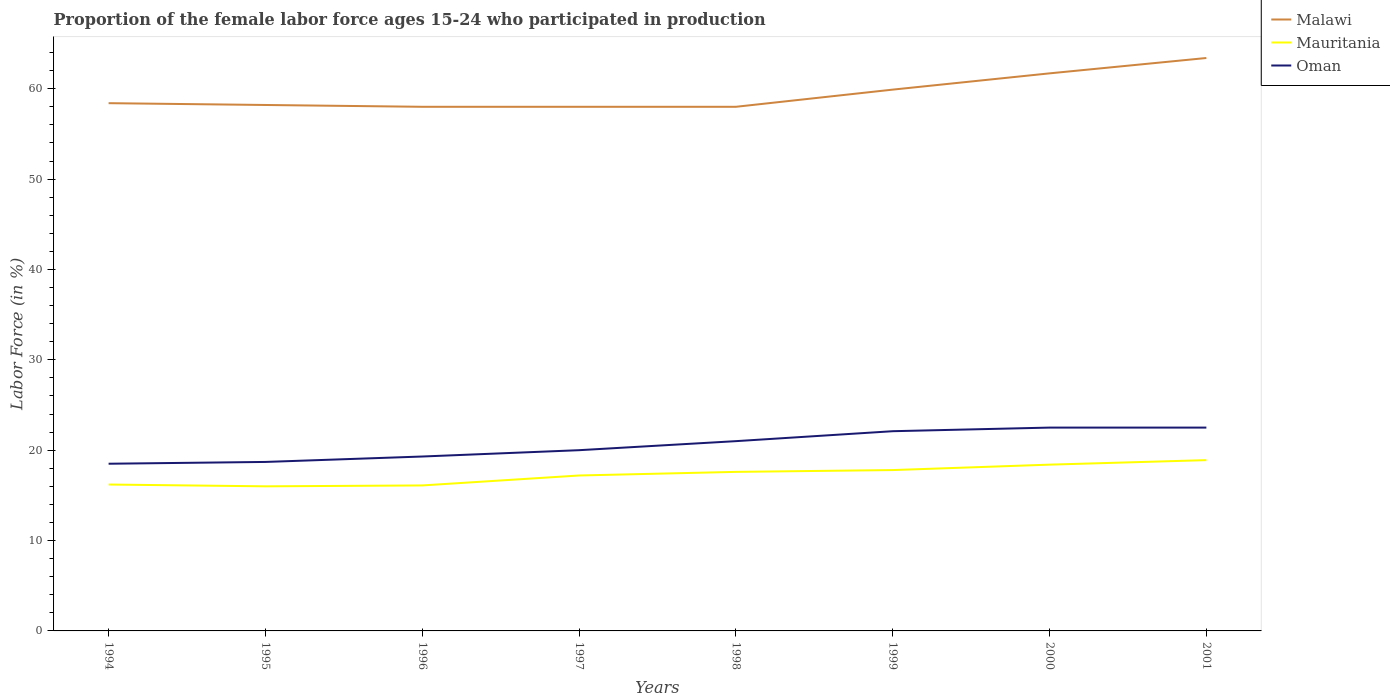How many different coloured lines are there?
Offer a very short reply. 3. Does the line corresponding to Oman intersect with the line corresponding to Malawi?
Make the answer very short. No. Is the number of lines equal to the number of legend labels?
Your response must be concise. Yes. Across all years, what is the maximum proportion of the female labor force who participated in production in Oman?
Ensure brevity in your answer.  18.5. What is the total proportion of the female labor force who participated in production in Oman in the graph?
Keep it short and to the point. -3.4. Is the proportion of the female labor force who participated in production in Malawi strictly greater than the proportion of the female labor force who participated in production in Mauritania over the years?
Ensure brevity in your answer.  No. Are the values on the major ticks of Y-axis written in scientific E-notation?
Offer a terse response. No. Does the graph contain any zero values?
Give a very brief answer. No. Does the graph contain grids?
Your answer should be compact. No. Where does the legend appear in the graph?
Ensure brevity in your answer.  Top right. How many legend labels are there?
Your answer should be very brief. 3. What is the title of the graph?
Make the answer very short. Proportion of the female labor force ages 15-24 who participated in production. What is the label or title of the X-axis?
Offer a very short reply. Years. What is the Labor Force (in %) of Malawi in 1994?
Provide a short and direct response. 58.4. What is the Labor Force (in %) of Mauritania in 1994?
Offer a very short reply. 16.2. What is the Labor Force (in %) in Oman in 1994?
Your answer should be very brief. 18.5. What is the Labor Force (in %) of Malawi in 1995?
Make the answer very short. 58.2. What is the Labor Force (in %) in Mauritania in 1995?
Give a very brief answer. 16. What is the Labor Force (in %) in Oman in 1995?
Offer a terse response. 18.7. What is the Labor Force (in %) of Malawi in 1996?
Offer a terse response. 58. What is the Labor Force (in %) in Mauritania in 1996?
Provide a short and direct response. 16.1. What is the Labor Force (in %) in Oman in 1996?
Make the answer very short. 19.3. What is the Labor Force (in %) of Malawi in 1997?
Provide a succinct answer. 58. What is the Labor Force (in %) in Mauritania in 1997?
Your answer should be compact. 17.2. What is the Labor Force (in %) in Oman in 1997?
Your answer should be very brief. 20. What is the Labor Force (in %) in Mauritania in 1998?
Provide a succinct answer. 17.6. What is the Labor Force (in %) in Oman in 1998?
Your answer should be very brief. 21. What is the Labor Force (in %) of Malawi in 1999?
Give a very brief answer. 59.9. What is the Labor Force (in %) of Mauritania in 1999?
Your answer should be very brief. 17.8. What is the Labor Force (in %) in Oman in 1999?
Your response must be concise. 22.1. What is the Labor Force (in %) of Malawi in 2000?
Your answer should be compact. 61.7. What is the Labor Force (in %) in Mauritania in 2000?
Your answer should be compact. 18.4. What is the Labor Force (in %) in Malawi in 2001?
Offer a very short reply. 63.4. What is the Labor Force (in %) of Mauritania in 2001?
Your response must be concise. 18.9. What is the Labor Force (in %) of Oman in 2001?
Offer a very short reply. 22.5. Across all years, what is the maximum Labor Force (in %) of Malawi?
Provide a short and direct response. 63.4. Across all years, what is the maximum Labor Force (in %) of Mauritania?
Your response must be concise. 18.9. Across all years, what is the maximum Labor Force (in %) in Oman?
Make the answer very short. 22.5. Across all years, what is the minimum Labor Force (in %) in Malawi?
Your answer should be very brief. 58. Across all years, what is the minimum Labor Force (in %) of Mauritania?
Your answer should be compact. 16. Across all years, what is the minimum Labor Force (in %) in Oman?
Offer a very short reply. 18.5. What is the total Labor Force (in %) in Malawi in the graph?
Give a very brief answer. 475.6. What is the total Labor Force (in %) in Mauritania in the graph?
Give a very brief answer. 138.2. What is the total Labor Force (in %) of Oman in the graph?
Offer a very short reply. 164.6. What is the difference between the Labor Force (in %) in Malawi in 1994 and that in 1995?
Provide a succinct answer. 0.2. What is the difference between the Labor Force (in %) of Mauritania in 1994 and that in 1995?
Your answer should be compact. 0.2. What is the difference between the Labor Force (in %) of Malawi in 1994 and that in 1996?
Your response must be concise. 0.4. What is the difference between the Labor Force (in %) of Oman in 1994 and that in 1996?
Your answer should be very brief. -0.8. What is the difference between the Labor Force (in %) in Malawi in 1994 and that in 1997?
Give a very brief answer. 0.4. What is the difference between the Labor Force (in %) of Mauritania in 1994 and that in 1997?
Offer a terse response. -1. What is the difference between the Labor Force (in %) in Oman in 1994 and that in 1998?
Your answer should be very brief. -2.5. What is the difference between the Labor Force (in %) of Mauritania in 1994 and that in 1999?
Ensure brevity in your answer.  -1.6. What is the difference between the Labor Force (in %) in Oman in 1994 and that in 1999?
Offer a very short reply. -3.6. What is the difference between the Labor Force (in %) of Malawi in 1994 and that in 2000?
Offer a terse response. -3.3. What is the difference between the Labor Force (in %) in Mauritania in 1994 and that in 2000?
Your response must be concise. -2.2. What is the difference between the Labor Force (in %) of Malawi in 1994 and that in 2001?
Make the answer very short. -5. What is the difference between the Labor Force (in %) of Mauritania in 1994 and that in 2001?
Provide a succinct answer. -2.7. What is the difference between the Labor Force (in %) in Malawi in 1995 and that in 1996?
Offer a very short reply. 0.2. What is the difference between the Labor Force (in %) in Mauritania in 1995 and that in 1997?
Keep it short and to the point. -1.2. What is the difference between the Labor Force (in %) of Oman in 1995 and that in 1997?
Offer a terse response. -1.3. What is the difference between the Labor Force (in %) of Malawi in 1995 and that in 1998?
Offer a very short reply. 0.2. What is the difference between the Labor Force (in %) in Malawi in 1995 and that in 1999?
Your response must be concise. -1.7. What is the difference between the Labor Force (in %) of Mauritania in 1995 and that in 1999?
Your response must be concise. -1.8. What is the difference between the Labor Force (in %) of Malawi in 1995 and that in 2000?
Make the answer very short. -3.5. What is the difference between the Labor Force (in %) of Malawi in 1995 and that in 2001?
Your answer should be compact. -5.2. What is the difference between the Labor Force (in %) in Mauritania in 1995 and that in 2001?
Give a very brief answer. -2.9. What is the difference between the Labor Force (in %) of Mauritania in 1996 and that in 1997?
Your response must be concise. -1.1. What is the difference between the Labor Force (in %) in Oman in 1996 and that in 1997?
Provide a short and direct response. -0.7. What is the difference between the Labor Force (in %) in Malawi in 1996 and that in 1998?
Offer a terse response. 0. What is the difference between the Labor Force (in %) of Mauritania in 1996 and that in 1998?
Provide a short and direct response. -1.5. What is the difference between the Labor Force (in %) in Oman in 1996 and that in 1998?
Ensure brevity in your answer.  -1.7. What is the difference between the Labor Force (in %) of Mauritania in 1996 and that in 1999?
Keep it short and to the point. -1.7. What is the difference between the Labor Force (in %) of Malawi in 1996 and that in 2000?
Your response must be concise. -3.7. What is the difference between the Labor Force (in %) of Oman in 1996 and that in 2000?
Your response must be concise. -3.2. What is the difference between the Labor Force (in %) in Oman in 1996 and that in 2001?
Keep it short and to the point. -3.2. What is the difference between the Labor Force (in %) of Mauritania in 1997 and that in 1998?
Offer a terse response. -0.4. What is the difference between the Labor Force (in %) in Oman in 1997 and that in 1998?
Your response must be concise. -1. What is the difference between the Labor Force (in %) in Malawi in 1997 and that in 2000?
Provide a succinct answer. -3.7. What is the difference between the Labor Force (in %) of Mauritania in 1997 and that in 2000?
Keep it short and to the point. -1.2. What is the difference between the Labor Force (in %) of Oman in 1997 and that in 2000?
Make the answer very short. -2.5. What is the difference between the Labor Force (in %) of Malawi in 1997 and that in 2001?
Give a very brief answer. -5.4. What is the difference between the Labor Force (in %) in Mauritania in 1997 and that in 2001?
Your answer should be compact. -1.7. What is the difference between the Labor Force (in %) in Malawi in 1998 and that in 1999?
Keep it short and to the point. -1.9. What is the difference between the Labor Force (in %) in Oman in 1998 and that in 1999?
Give a very brief answer. -1.1. What is the difference between the Labor Force (in %) of Mauritania in 1998 and that in 2000?
Provide a succinct answer. -0.8. What is the difference between the Labor Force (in %) of Malawi in 1998 and that in 2001?
Offer a very short reply. -5.4. What is the difference between the Labor Force (in %) in Mauritania in 1999 and that in 2000?
Offer a terse response. -0.6. What is the difference between the Labor Force (in %) of Malawi in 1999 and that in 2001?
Your answer should be very brief. -3.5. What is the difference between the Labor Force (in %) in Mauritania in 1999 and that in 2001?
Make the answer very short. -1.1. What is the difference between the Labor Force (in %) of Oman in 1999 and that in 2001?
Give a very brief answer. -0.4. What is the difference between the Labor Force (in %) in Oman in 2000 and that in 2001?
Keep it short and to the point. 0. What is the difference between the Labor Force (in %) in Malawi in 1994 and the Labor Force (in %) in Mauritania in 1995?
Provide a succinct answer. 42.4. What is the difference between the Labor Force (in %) in Malawi in 1994 and the Labor Force (in %) in Oman in 1995?
Offer a terse response. 39.7. What is the difference between the Labor Force (in %) of Malawi in 1994 and the Labor Force (in %) of Mauritania in 1996?
Provide a short and direct response. 42.3. What is the difference between the Labor Force (in %) in Malawi in 1994 and the Labor Force (in %) in Oman in 1996?
Offer a terse response. 39.1. What is the difference between the Labor Force (in %) in Mauritania in 1994 and the Labor Force (in %) in Oman in 1996?
Ensure brevity in your answer.  -3.1. What is the difference between the Labor Force (in %) in Malawi in 1994 and the Labor Force (in %) in Mauritania in 1997?
Make the answer very short. 41.2. What is the difference between the Labor Force (in %) of Malawi in 1994 and the Labor Force (in %) of Oman in 1997?
Your answer should be compact. 38.4. What is the difference between the Labor Force (in %) of Mauritania in 1994 and the Labor Force (in %) of Oman in 1997?
Make the answer very short. -3.8. What is the difference between the Labor Force (in %) of Malawi in 1994 and the Labor Force (in %) of Mauritania in 1998?
Offer a terse response. 40.8. What is the difference between the Labor Force (in %) in Malawi in 1994 and the Labor Force (in %) in Oman in 1998?
Your answer should be very brief. 37.4. What is the difference between the Labor Force (in %) in Mauritania in 1994 and the Labor Force (in %) in Oman in 1998?
Offer a terse response. -4.8. What is the difference between the Labor Force (in %) in Malawi in 1994 and the Labor Force (in %) in Mauritania in 1999?
Provide a short and direct response. 40.6. What is the difference between the Labor Force (in %) of Malawi in 1994 and the Labor Force (in %) of Oman in 1999?
Your answer should be very brief. 36.3. What is the difference between the Labor Force (in %) in Mauritania in 1994 and the Labor Force (in %) in Oman in 1999?
Your response must be concise. -5.9. What is the difference between the Labor Force (in %) of Malawi in 1994 and the Labor Force (in %) of Mauritania in 2000?
Your answer should be very brief. 40. What is the difference between the Labor Force (in %) of Malawi in 1994 and the Labor Force (in %) of Oman in 2000?
Offer a terse response. 35.9. What is the difference between the Labor Force (in %) in Malawi in 1994 and the Labor Force (in %) in Mauritania in 2001?
Provide a succinct answer. 39.5. What is the difference between the Labor Force (in %) of Malawi in 1994 and the Labor Force (in %) of Oman in 2001?
Provide a succinct answer. 35.9. What is the difference between the Labor Force (in %) of Malawi in 1995 and the Labor Force (in %) of Mauritania in 1996?
Offer a very short reply. 42.1. What is the difference between the Labor Force (in %) in Malawi in 1995 and the Labor Force (in %) in Oman in 1996?
Give a very brief answer. 38.9. What is the difference between the Labor Force (in %) of Mauritania in 1995 and the Labor Force (in %) of Oman in 1996?
Provide a succinct answer. -3.3. What is the difference between the Labor Force (in %) in Malawi in 1995 and the Labor Force (in %) in Oman in 1997?
Make the answer very short. 38.2. What is the difference between the Labor Force (in %) of Malawi in 1995 and the Labor Force (in %) of Mauritania in 1998?
Your response must be concise. 40.6. What is the difference between the Labor Force (in %) of Malawi in 1995 and the Labor Force (in %) of Oman in 1998?
Give a very brief answer. 37.2. What is the difference between the Labor Force (in %) in Malawi in 1995 and the Labor Force (in %) in Mauritania in 1999?
Your response must be concise. 40.4. What is the difference between the Labor Force (in %) in Malawi in 1995 and the Labor Force (in %) in Oman in 1999?
Give a very brief answer. 36.1. What is the difference between the Labor Force (in %) of Malawi in 1995 and the Labor Force (in %) of Mauritania in 2000?
Offer a terse response. 39.8. What is the difference between the Labor Force (in %) of Malawi in 1995 and the Labor Force (in %) of Oman in 2000?
Provide a short and direct response. 35.7. What is the difference between the Labor Force (in %) of Malawi in 1995 and the Labor Force (in %) of Mauritania in 2001?
Keep it short and to the point. 39.3. What is the difference between the Labor Force (in %) of Malawi in 1995 and the Labor Force (in %) of Oman in 2001?
Give a very brief answer. 35.7. What is the difference between the Labor Force (in %) in Mauritania in 1995 and the Labor Force (in %) in Oman in 2001?
Give a very brief answer. -6.5. What is the difference between the Labor Force (in %) of Malawi in 1996 and the Labor Force (in %) of Mauritania in 1997?
Your response must be concise. 40.8. What is the difference between the Labor Force (in %) of Malawi in 1996 and the Labor Force (in %) of Oman in 1997?
Provide a succinct answer. 38. What is the difference between the Labor Force (in %) of Malawi in 1996 and the Labor Force (in %) of Mauritania in 1998?
Offer a terse response. 40.4. What is the difference between the Labor Force (in %) of Mauritania in 1996 and the Labor Force (in %) of Oman in 1998?
Offer a terse response. -4.9. What is the difference between the Labor Force (in %) of Malawi in 1996 and the Labor Force (in %) of Mauritania in 1999?
Your answer should be very brief. 40.2. What is the difference between the Labor Force (in %) in Malawi in 1996 and the Labor Force (in %) in Oman in 1999?
Give a very brief answer. 35.9. What is the difference between the Labor Force (in %) of Mauritania in 1996 and the Labor Force (in %) of Oman in 1999?
Your answer should be compact. -6. What is the difference between the Labor Force (in %) of Malawi in 1996 and the Labor Force (in %) of Mauritania in 2000?
Provide a short and direct response. 39.6. What is the difference between the Labor Force (in %) in Malawi in 1996 and the Labor Force (in %) in Oman in 2000?
Offer a terse response. 35.5. What is the difference between the Labor Force (in %) of Mauritania in 1996 and the Labor Force (in %) of Oman in 2000?
Keep it short and to the point. -6.4. What is the difference between the Labor Force (in %) in Malawi in 1996 and the Labor Force (in %) in Mauritania in 2001?
Make the answer very short. 39.1. What is the difference between the Labor Force (in %) in Malawi in 1996 and the Labor Force (in %) in Oman in 2001?
Provide a succinct answer. 35.5. What is the difference between the Labor Force (in %) of Mauritania in 1996 and the Labor Force (in %) of Oman in 2001?
Offer a terse response. -6.4. What is the difference between the Labor Force (in %) in Malawi in 1997 and the Labor Force (in %) in Mauritania in 1998?
Provide a succinct answer. 40.4. What is the difference between the Labor Force (in %) of Malawi in 1997 and the Labor Force (in %) of Oman in 1998?
Give a very brief answer. 37. What is the difference between the Labor Force (in %) in Malawi in 1997 and the Labor Force (in %) in Mauritania in 1999?
Provide a short and direct response. 40.2. What is the difference between the Labor Force (in %) in Malawi in 1997 and the Labor Force (in %) in Oman in 1999?
Give a very brief answer. 35.9. What is the difference between the Labor Force (in %) of Mauritania in 1997 and the Labor Force (in %) of Oman in 1999?
Make the answer very short. -4.9. What is the difference between the Labor Force (in %) in Malawi in 1997 and the Labor Force (in %) in Mauritania in 2000?
Provide a short and direct response. 39.6. What is the difference between the Labor Force (in %) in Malawi in 1997 and the Labor Force (in %) in Oman in 2000?
Provide a succinct answer. 35.5. What is the difference between the Labor Force (in %) in Malawi in 1997 and the Labor Force (in %) in Mauritania in 2001?
Make the answer very short. 39.1. What is the difference between the Labor Force (in %) of Malawi in 1997 and the Labor Force (in %) of Oman in 2001?
Make the answer very short. 35.5. What is the difference between the Labor Force (in %) of Mauritania in 1997 and the Labor Force (in %) of Oman in 2001?
Make the answer very short. -5.3. What is the difference between the Labor Force (in %) in Malawi in 1998 and the Labor Force (in %) in Mauritania in 1999?
Provide a short and direct response. 40.2. What is the difference between the Labor Force (in %) in Malawi in 1998 and the Labor Force (in %) in Oman in 1999?
Your response must be concise. 35.9. What is the difference between the Labor Force (in %) of Malawi in 1998 and the Labor Force (in %) of Mauritania in 2000?
Your answer should be compact. 39.6. What is the difference between the Labor Force (in %) in Malawi in 1998 and the Labor Force (in %) in Oman in 2000?
Make the answer very short. 35.5. What is the difference between the Labor Force (in %) in Malawi in 1998 and the Labor Force (in %) in Mauritania in 2001?
Give a very brief answer. 39.1. What is the difference between the Labor Force (in %) of Malawi in 1998 and the Labor Force (in %) of Oman in 2001?
Your response must be concise. 35.5. What is the difference between the Labor Force (in %) of Mauritania in 1998 and the Labor Force (in %) of Oman in 2001?
Provide a short and direct response. -4.9. What is the difference between the Labor Force (in %) in Malawi in 1999 and the Labor Force (in %) in Mauritania in 2000?
Provide a short and direct response. 41.5. What is the difference between the Labor Force (in %) in Malawi in 1999 and the Labor Force (in %) in Oman in 2000?
Offer a terse response. 37.4. What is the difference between the Labor Force (in %) of Mauritania in 1999 and the Labor Force (in %) of Oman in 2000?
Ensure brevity in your answer.  -4.7. What is the difference between the Labor Force (in %) in Malawi in 1999 and the Labor Force (in %) in Mauritania in 2001?
Offer a very short reply. 41. What is the difference between the Labor Force (in %) in Malawi in 1999 and the Labor Force (in %) in Oman in 2001?
Keep it short and to the point. 37.4. What is the difference between the Labor Force (in %) in Mauritania in 1999 and the Labor Force (in %) in Oman in 2001?
Provide a short and direct response. -4.7. What is the difference between the Labor Force (in %) in Malawi in 2000 and the Labor Force (in %) in Mauritania in 2001?
Your response must be concise. 42.8. What is the difference between the Labor Force (in %) in Malawi in 2000 and the Labor Force (in %) in Oman in 2001?
Ensure brevity in your answer.  39.2. What is the average Labor Force (in %) of Malawi per year?
Offer a very short reply. 59.45. What is the average Labor Force (in %) of Mauritania per year?
Keep it short and to the point. 17.27. What is the average Labor Force (in %) in Oman per year?
Ensure brevity in your answer.  20.57. In the year 1994, what is the difference between the Labor Force (in %) of Malawi and Labor Force (in %) of Mauritania?
Keep it short and to the point. 42.2. In the year 1994, what is the difference between the Labor Force (in %) in Malawi and Labor Force (in %) in Oman?
Offer a very short reply. 39.9. In the year 1994, what is the difference between the Labor Force (in %) of Mauritania and Labor Force (in %) of Oman?
Provide a short and direct response. -2.3. In the year 1995, what is the difference between the Labor Force (in %) in Malawi and Labor Force (in %) in Mauritania?
Your answer should be very brief. 42.2. In the year 1995, what is the difference between the Labor Force (in %) of Malawi and Labor Force (in %) of Oman?
Make the answer very short. 39.5. In the year 1995, what is the difference between the Labor Force (in %) in Mauritania and Labor Force (in %) in Oman?
Offer a very short reply. -2.7. In the year 1996, what is the difference between the Labor Force (in %) of Malawi and Labor Force (in %) of Mauritania?
Provide a short and direct response. 41.9. In the year 1996, what is the difference between the Labor Force (in %) of Malawi and Labor Force (in %) of Oman?
Offer a very short reply. 38.7. In the year 1996, what is the difference between the Labor Force (in %) of Mauritania and Labor Force (in %) of Oman?
Ensure brevity in your answer.  -3.2. In the year 1997, what is the difference between the Labor Force (in %) of Malawi and Labor Force (in %) of Mauritania?
Your answer should be very brief. 40.8. In the year 1998, what is the difference between the Labor Force (in %) of Malawi and Labor Force (in %) of Mauritania?
Your response must be concise. 40.4. In the year 1998, what is the difference between the Labor Force (in %) of Malawi and Labor Force (in %) of Oman?
Your answer should be very brief. 37. In the year 1999, what is the difference between the Labor Force (in %) of Malawi and Labor Force (in %) of Mauritania?
Your answer should be very brief. 42.1. In the year 1999, what is the difference between the Labor Force (in %) of Malawi and Labor Force (in %) of Oman?
Keep it short and to the point. 37.8. In the year 1999, what is the difference between the Labor Force (in %) in Mauritania and Labor Force (in %) in Oman?
Ensure brevity in your answer.  -4.3. In the year 2000, what is the difference between the Labor Force (in %) in Malawi and Labor Force (in %) in Mauritania?
Provide a succinct answer. 43.3. In the year 2000, what is the difference between the Labor Force (in %) in Malawi and Labor Force (in %) in Oman?
Make the answer very short. 39.2. In the year 2000, what is the difference between the Labor Force (in %) of Mauritania and Labor Force (in %) of Oman?
Make the answer very short. -4.1. In the year 2001, what is the difference between the Labor Force (in %) in Malawi and Labor Force (in %) in Mauritania?
Provide a succinct answer. 44.5. In the year 2001, what is the difference between the Labor Force (in %) of Malawi and Labor Force (in %) of Oman?
Ensure brevity in your answer.  40.9. What is the ratio of the Labor Force (in %) of Malawi in 1994 to that in 1995?
Provide a short and direct response. 1. What is the ratio of the Labor Force (in %) in Mauritania in 1994 to that in 1995?
Keep it short and to the point. 1.01. What is the ratio of the Labor Force (in %) of Oman in 1994 to that in 1995?
Make the answer very short. 0.99. What is the ratio of the Labor Force (in %) of Malawi in 1994 to that in 1996?
Give a very brief answer. 1.01. What is the ratio of the Labor Force (in %) of Mauritania in 1994 to that in 1996?
Your answer should be compact. 1.01. What is the ratio of the Labor Force (in %) of Oman in 1994 to that in 1996?
Offer a very short reply. 0.96. What is the ratio of the Labor Force (in %) of Mauritania in 1994 to that in 1997?
Offer a terse response. 0.94. What is the ratio of the Labor Force (in %) in Oman in 1994 to that in 1997?
Offer a terse response. 0.93. What is the ratio of the Labor Force (in %) of Malawi in 1994 to that in 1998?
Your response must be concise. 1.01. What is the ratio of the Labor Force (in %) in Mauritania in 1994 to that in 1998?
Ensure brevity in your answer.  0.92. What is the ratio of the Labor Force (in %) in Oman in 1994 to that in 1998?
Make the answer very short. 0.88. What is the ratio of the Labor Force (in %) of Malawi in 1994 to that in 1999?
Your answer should be compact. 0.97. What is the ratio of the Labor Force (in %) of Mauritania in 1994 to that in 1999?
Your response must be concise. 0.91. What is the ratio of the Labor Force (in %) in Oman in 1994 to that in 1999?
Offer a terse response. 0.84. What is the ratio of the Labor Force (in %) in Malawi in 1994 to that in 2000?
Keep it short and to the point. 0.95. What is the ratio of the Labor Force (in %) in Mauritania in 1994 to that in 2000?
Your response must be concise. 0.88. What is the ratio of the Labor Force (in %) of Oman in 1994 to that in 2000?
Your response must be concise. 0.82. What is the ratio of the Labor Force (in %) of Malawi in 1994 to that in 2001?
Make the answer very short. 0.92. What is the ratio of the Labor Force (in %) in Oman in 1994 to that in 2001?
Your answer should be very brief. 0.82. What is the ratio of the Labor Force (in %) of Malawi in 1995 to that in 1996?
Your answer should be compact. 1. What is the ratio of the Labor Force (in %) of Mauritania in 1995 to that in 1996?
Your answer should be compact. 0.99. What is the ratio of the Labor Force (in %) of Oman in 1995 to that in 1996?
Make the answer very short. 0.97. What is the ratio of the Labor Force (in %) of Malawi in 1995 to that in 1997?
Keep it short and to the point. 1. What is the ratio of the Labor Force (in %) in Mauritania in 1995 to that in 1997?
Keep it short and to the point. 0.93. What is the ratio of the Labor Force (in %) of Oman in 1995 to that in 1997?
Make the answer very short. 0.94. What is the ratio of the Labor Force (in %) of Malawi in 1995 to that in 1998?
Give a very brief answer. 1. What is the ratio of the Labor Force (in %) of Mauritania in 1995 to that in 1998?
Keep it short and to the point. 0.91. What is the ratio of the Labor Force (in %) of Oman in 1995 to that in 1998?
Your response must be concise. 0.89. What is the ratio of the Labor Force (in %) in Malawi in 1995 to that in 1999?
Keep it short and to the point. 0.97. What is the ratio of the Labor Force (in %) in Mauritania in 1995 to that in 1999?
Keep it short and to the point. 0.9. What is the ratio of the Labor Force (in %) in Oman in 1995 to that in 1999?
Provide a succinct answer. 0.85. What is the ratio of the Labor Force (in %) of Malawi in 1995 to that in 2000?
Ensure brevity in your answer.  0.94. What is the ratio of the Labor Force (in %) in Mauritania in 1995 to that in 2000?
Offer a very short reply. 0.87. What is the ratio of the Labor Force (in %) in Oman in 1995 to that in 2000?
Make the answer very short. 0.83. What is the ratio of the Labor Force (in %) in Malawi in 1995 to that in 2001?
Provide a succinct answer. 0.92. What is the ratio of the Labor Force (in %) of Mauritania in 1995 to that in 2001?
Keep it short and to the point. 0.85. What is the ratio of the Labor Force (in %) of Oman in 1995 to that in 2001?
Your answer should be very brief. 0.83. What is the ratio of the Labor Force (in %) in Mauritania in 1996 to that in 1997?
Provide a succinct answer. 0.94. What is the ratio of the Labor Force (in %) of Mauritania in 1996 to that in 1998?
Offer a very short reply. 0.91. What is the ratio of the Labor Force (in %) in Oman in 1996 to that in 1998?
Give a very brief answer. 0.92. What is the ratio of the Labor Force (in %) in Malawi in 1996 to that in 1999?
Keep it short and to the point. 0.97. What is the ratio of the Labor Force (in %) of Mauritania in 1996 to that in 1999?
Offer a terse response. 0.9. What is the ratio of the Labor Force (in %) in Oman in 1996 to that in 1999?
Your response must be concise. 0.87. What is the ratio of the Labor Force (in %) in Mauritania in 1996 to that in 2000?
Keep it short and to the point. 0.88. What is the ratio of the Labor Force (in %) in Oman in 1996 to that in 2000?
Keep it short and to the point. 0.86. What is the ratio of the Labor Force (in %) in Malawi in 1996 to that in 2001?
Provide a short and direct response. 0.91. What is the ratio of the Labor Force (in %) of Mauritania in 1996 to that in 2001?
Provide a succinct answer. 0.85. What is the ratio of the Labor Force (in %) of Oman in 1996 to that in 2001?
Provide a short and direct response. 0.86. What is the ratio of the Labor Force (in %) of Mauritania in 1997 to that in 1998?
Give a very brief answer. 0.98. What is the ratio of the Labor Force (in %) in Oman in 1997 to that in 1998?
Your response must be concise. 0.95. What is the ratio of the Labor Force (in %) in Malawi in 1997 to that in 1999?
Offer a very short reply. 0.97. What is the ratio of the Labor Force (in %) of Mauritania in 1997 to that in 1999?
Your answer should be compact. 0.97. What is the ratio of the Labor Force (in %) in Oman in 1997 to that in 1999?
Provide a succinct answer. 0.91. What is the ratio of the Labor Force (in %) in Malawi in 1997 to that in 2000?
Your response must be concise. 0.94. What is the ratio of the Labor Force (in %) of Mauritania in 1997 to that in 2000?
Give a very brief answer. 0.93. What is the ratio of the Labor Force (in %) of Oman in 1997 to that in 2000?
Offer a very short reply. 0.89. What is the ratio of the Labor Force (in %) in Malawi in 1997 to that in 2001?
Provide a short and direct response. 0.91. What is the ratio of the Labor Force (in %) of Mauritania in 1997 to that in 2001?
Ensure brevity in your answer.  0.91. What is the ratio of the Labor Force (in %) of Malawi in 1998 to that in 1999?
Keep it short and to the point. 0.97. What is the ratio of the Labor Force (in %) of Oman in 1998 to that in 1999?
Offer a very short reply. 0.95. What is the ratio of the Labor Force (in %) in Mauritania in 1998 to that in 2000?
Your answer should be compact. 0.96. What is the ratio of the Labor Force (in %) of Oman in 1998 to that in 2000?
Give a very brief answer. 0.93. What is the ratio of the Labor Force (in %) of Malawi in 1998 to that in 2001?
Give a very brief answer. 0.91. What is the ratio of the Labor Force (in %) of Mauritania in 1998 to that in 2001?
Your answer should be compact. 0.93. What is the ratio of the Labor Force (in %) in Oman in 1998 to that in 2001?
Offer a terse response. 0.93. What is the ratio of the Labor Force (in %) in Malawi in 1999 to that in 2000?
Provide a succinct answer. 0.97. What is the ratio of the Labor Force (in %) of Mauritania in 1999 to that in 2000?
Provide a short and direct response. 0.97. What is the ratio of the Labor Force (in %) of Oman in 1999 to that in 2000?
Offer a terse response. 0.98. What is the ratio of the Labor Force (in %) of Malawi in 1999 to that in 2001?
Give a very brief answer. 0.94. What is the ratio of the Labor Force (in %) in Mauritania in 1999 to that in 2001?
Provide a short and direct response. 0.94. What is the ratio of the Labor Force (in %) in Oman in 1999 to that in 2001?
Provide a short and direct response. 0.98. What is the ratio of the Labor Force (in %) in Malawi in 2000 to that in 2001?
Provide a succinct answer. 0.97. What is the ratio of the Labor Force (in %) in Mauritania in 2000 to that in 2001?
Your answer should be very brief. 0.97. What is the difference between the highest and the second highest Labor Force (in %) in Malawi?
Make the answer very short. 1.7. What is the difference between the highest and the second highest Labor Force (in %) of Mauritania?
Ensure brevity in your answer.  0.5. What is the difference between the highest and the second highest Labor Force (in %) in Oman?
Your answer should be compact. 0. What is the difference between the highest and the lowest Labor Force (in %) of Mauritania?
Provide a succinct answer. 2.9. 